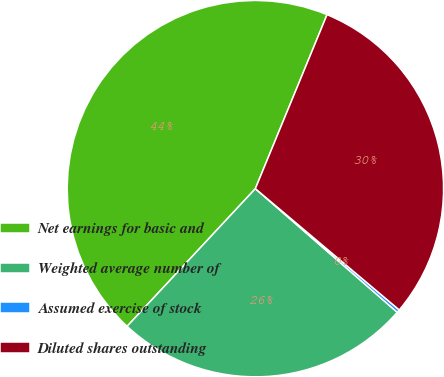Convert chart to OTSL. <chart><loc_0><loc_0><loc_500><loc_500><pie_chart><fcel>Net earnings for basic and<fcel>Weighted average number of<fcel>Assumed exercise of stock<fcel>Diluted shares outstanding<nl><fcel>44.28%<fcel>25.53%<fcel>0.26%<fcel>29.93%<nl></chart> 